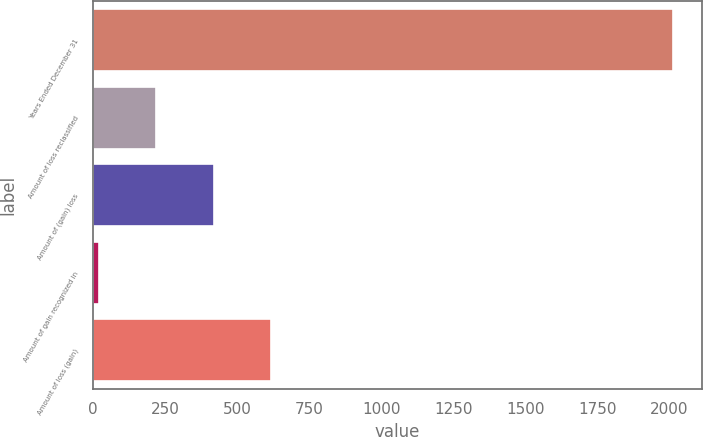Convert chart to OTSL. <chart><loc_0><loc_0><loc_500><loc_500><bar_chart><fcel>Years Ended December 31<fcel>Amount of loss reclassified<fcel>Amount of (gain) loss<fcel>Amount of gain recognized in<fcel>Amount of loss (gain)<nl><fcel>2012<fcel>219.2<fcel>418.4<fcel>20<fcel>617.6<nl></chart> 